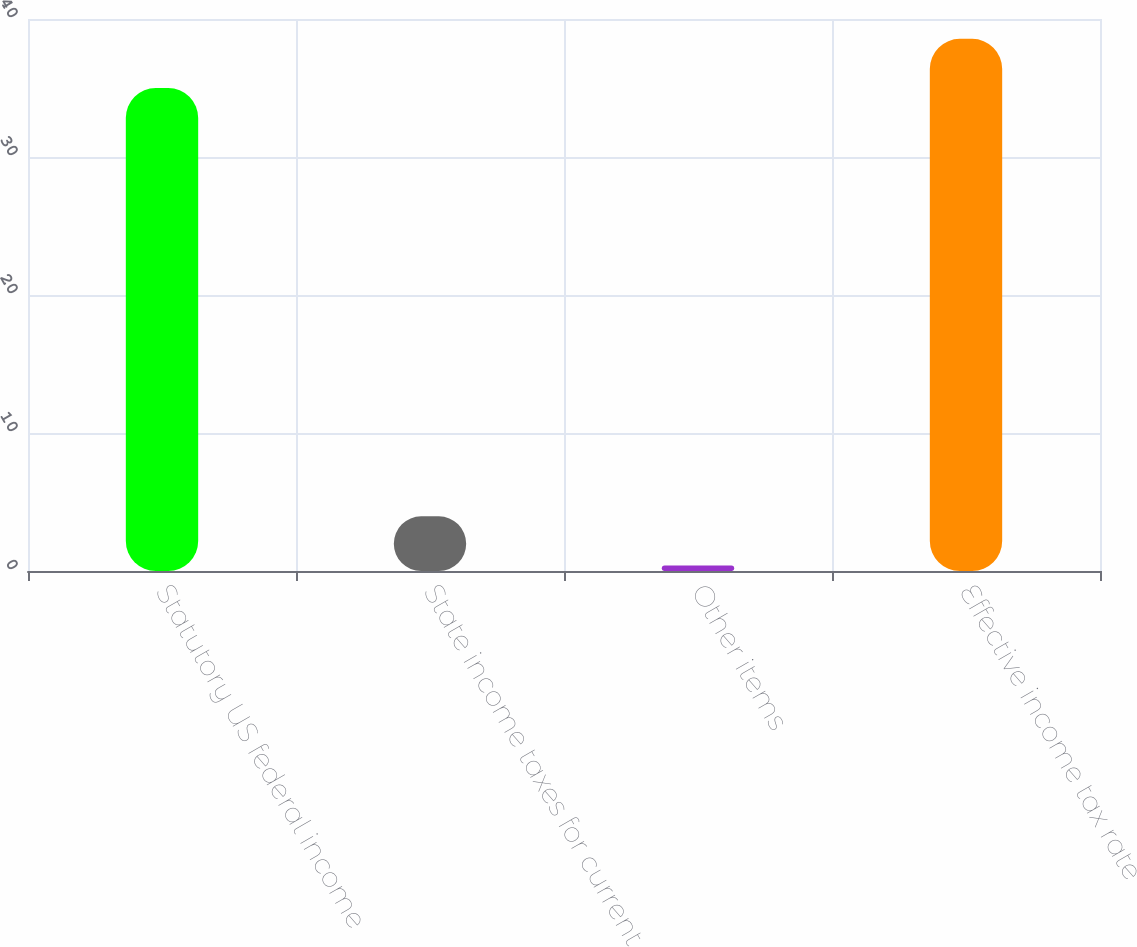Convert chart to OTSL. <chart><loc_0><loc_0><loc_500><loc_500><bar_chart><fcel>Statutory US federal income<fcel>State income taxes for current<fcel>Other items<fcel>Effective income tax rate<nl><fcel>35<fcel>3.96<fcel>0.4<fcel>38.56<nl></chart> 